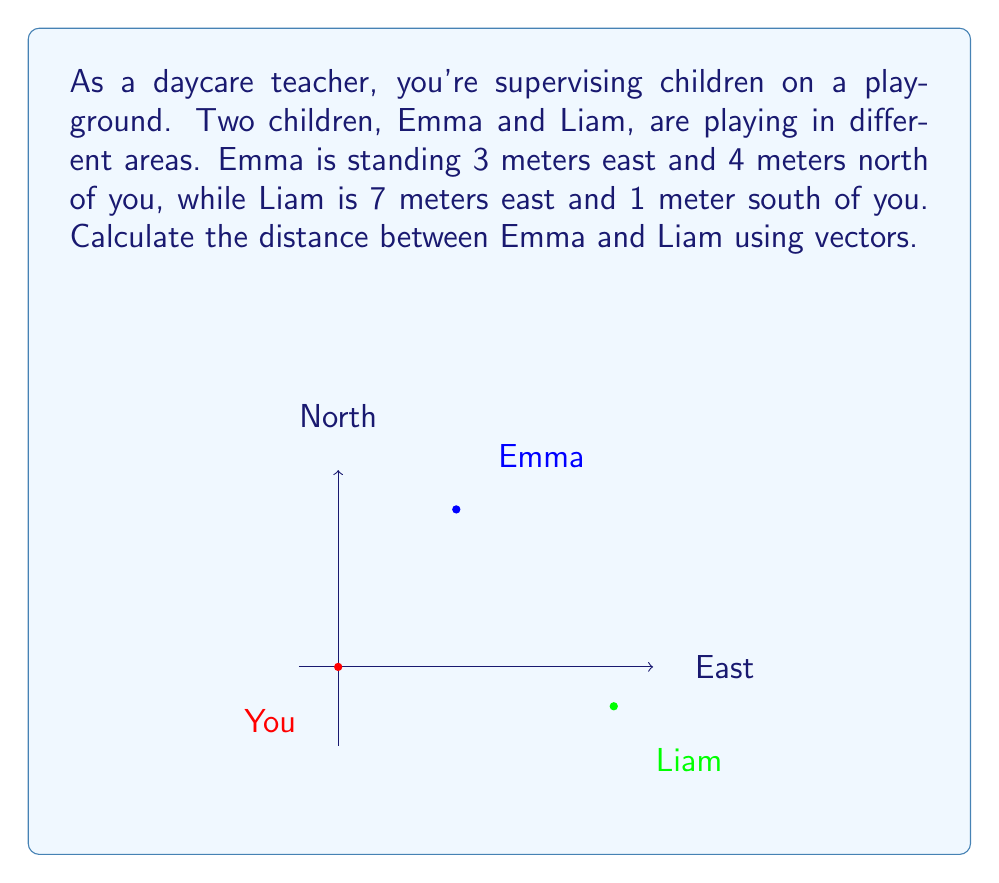Could you help me with this problem? Let's solve this step-by-step using vectors:

1) First, let's define vectors from your position to Emma and Liam:

   Vector to Emma: $\vec{E} = \langle 3, 4 \rangle$
   Vector to Liam: $\vec{L} = \langle 7, -1 \rangle$

2) To find the vector from Emma to Liam, we subtract Emma's vector from Liam's vector:

   $\vec{EL} = \vec{L} - \vec{E} = \langle 7, -1 \rangle - \langle 3, 4 \rangle = \langle 4, -5 \rangle$

3) Now that we have the vector from Emma to Liam, we can calculate its magnitude, which will give us the distance between them. We use the Pythagorean theorem:

   $$\text{Distance} = \sqrt{(\text{x component})^2 + (\text{y component})^2}$$

   $$\text{Distance} = \sqrt{4^2 + (-5)^2} = \sqrt{16 + 25} = \sqrt{41}$$

4) Simplify:

   $$\text{Distance} = \sqrt{41} \approx 6.40 \text{ meters}$$
Answer: $\sqrt{41}$ meters (approximately 6.40 meters) 